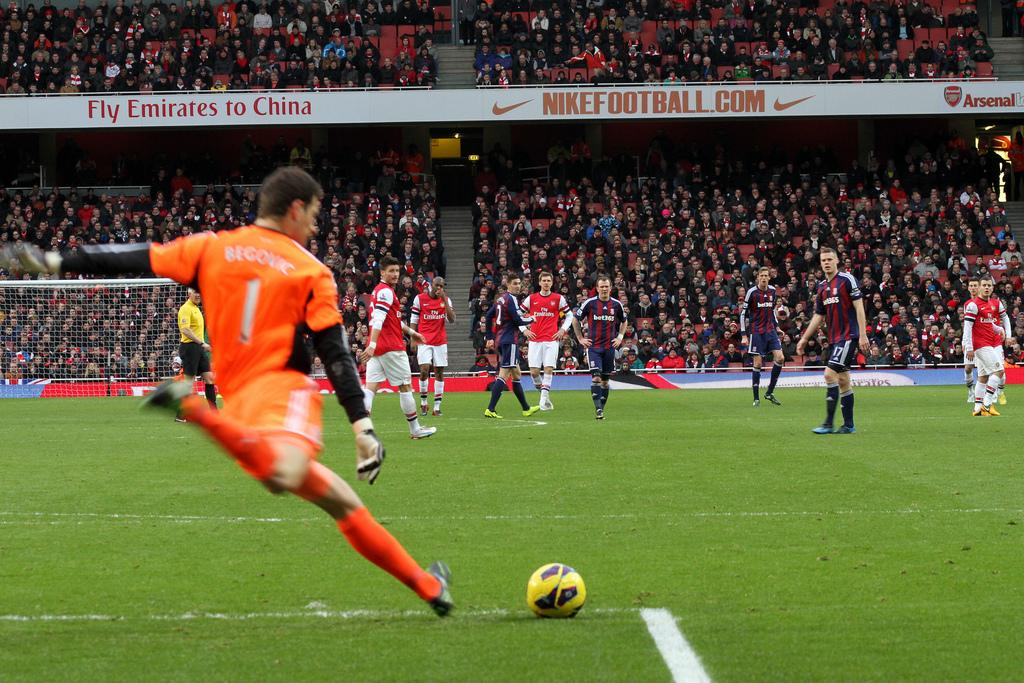Describe the color and appearance of the soccer ball on the field. The soccer ball has a yellow and blue design, with black patterns and appears new and unused. State the major sports brands advertised in the image. Nike and Emirates Airlines are the major sports brands advertised in the stadium. Briefly mention where the crowd is seated in the stadium. The crowd is seated in the lower and upper tiers of the stand, cheering on the game below. Write a concise caption that highlights the primary activity happening in the image. Soccer players in vibrant uniforms compete intensely over a yellow and blue soccer ball in a packed stadium. Narrate briefly about the condition of the soccer field. It is a pristine soccer field with green grass, white chalk lines, and a vivid soccer goal. Describe any noticeable actions by the soccer players on the field. A soccer player in an orange uniform attempts to kick the ball, while others rush to block or intercept. Mention the primary colors of the soccer players' uniforms present in the scene. The soccer players have orange, maroon and black, red and white, and yellow jerseys. Enumerate the prominent advertisements seen in the image. Advertisements for Emirates Airlines, Nike Football website, and a white sign with red writing are visible. Provide a brief overview of the setting, mentioning the location and ongoing activity. The image depicts a soccer game underway in a packed stadium, with players in motion and intense competition. Enumerate the various key elements present in the image. Soccer players, a soccer ball, a soccer goal, white chalk lines, advertisements, and spectators are present. 